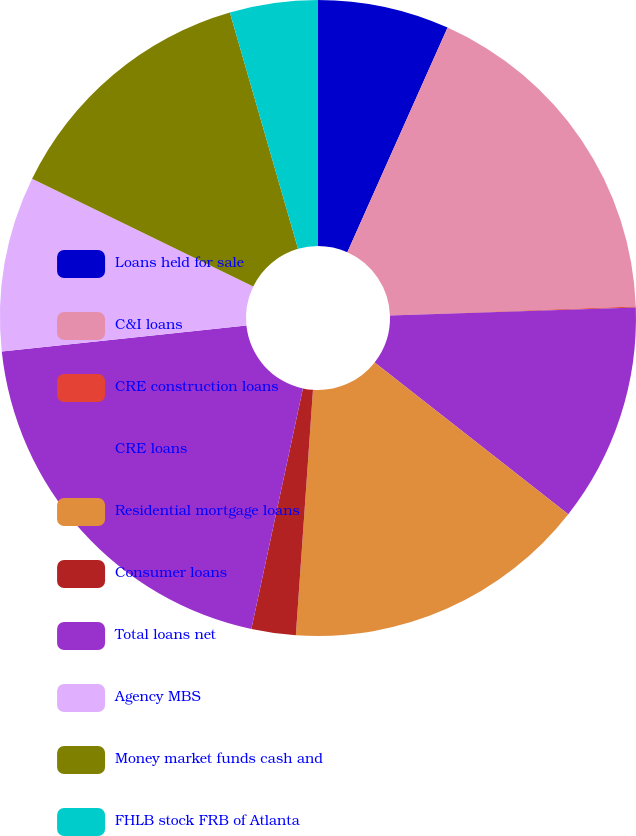Convert chart. <chart><loc_0><loc_0><loc_500><loc_500><pie_chart><fcel>Loans held for sale<fcel>C&I loans<fcel>CRE construction loans<fcel>CRE loans<fcel>Residential mortgage loans<fcel>Consumer loans<fcel>Total loans net<fcel>Agency MBS<fcel>Money market funds cash and<fcel>FHLB stock FRB of Atlanta<nl><fcel>6.68%<fcel>17.75%<fcel>0.04%<fcel>11.11%<fcel>15.53%<fcel>2.25%<fcel>19.96%<fcel>8.89%<fcel>13.32%<fcel>4.47%<nl></chart> 